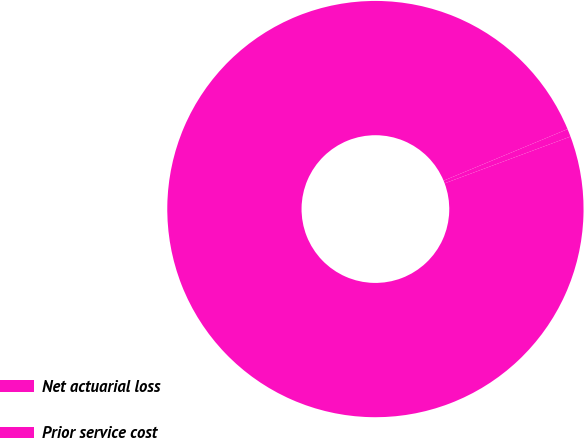<chart> <loc_0><loc_0><loc_500><loc_500><pie_chart><fcel>Net actuarial loss<fcel>Prior service cost<nl><fcel>99.39%<fcel>0.61%<nl></chart> 